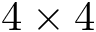<formula> <loc_0><loc_0><loc_500><loc_500>4 \times 4</formula> 